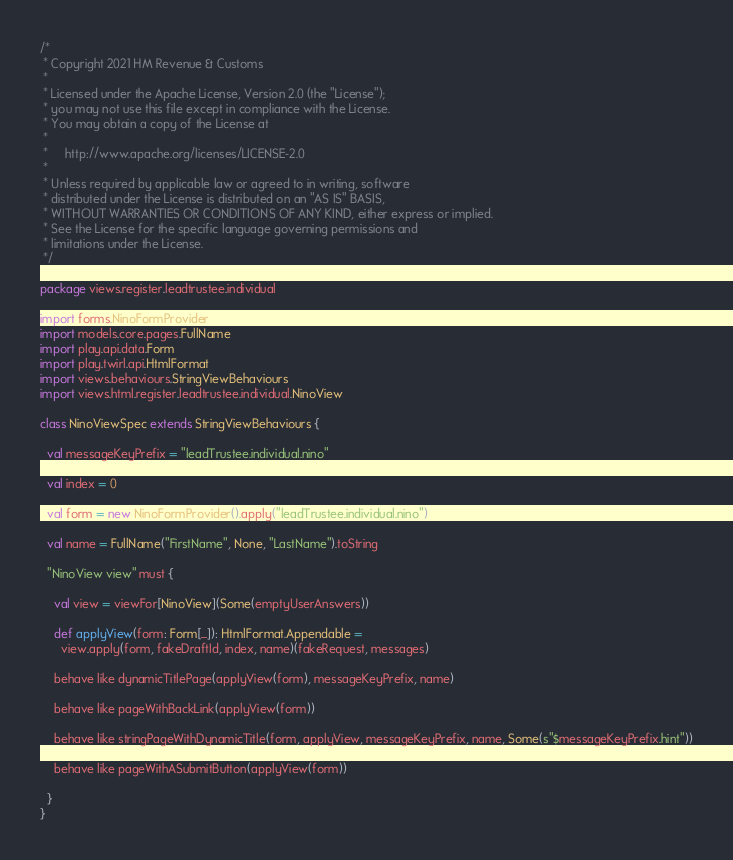Convert code to text. <code><loc_0><loc_0><loc_500><loc_500><_Scala_>/*
 * Copyright 2021 HM Revenue & Customs
 *
 * Licensed under the Apache License, Version 2.0 (the "License");
 * you may not use this file except in compliance with the License.
 * You may obtain a copy of the License at
 *
 *     http://www.apache.org/licenses/LICENSE-2.0
 *
 * Unless required by applicable law or agreed to in writing, software
 * distributed under the License is distributed on an "AS IS" BASIS,
 * WITHOUT WARRANTIES OR CONDITIONS OF ANY KIND, either express or implied.
 * See the License for the specific language governing permissions and
 * limitations under the License.
 */

package views.register.leadtrustee.individual

import forms.NinoFormProvider
import models.core.pages.FullName
import play.api.data.Form
import play.twirl.api.HtmlFormat
import views.behaviours.StringViewBehaviours
import views.html.register.leadtrustee.individual.NinoView

class NinoViewSpec extends StringViewBehaviours {

  val messageKeyPrefix = "leadTrustee.individual.nino"

  val index = 0

  val form = new NinoFormProvider().apply("leadTrustee.individual.nino")

  val name = FullName("FirstName", None, "LastName").toString

  "NinoView view" must {

    val view = viewFor[NinoView](Some(emptyUserAnswers))

    def applyView(form: Form[_]): HtmlFormat.Appendable =
      view.apply(form, fakeDraftId, index, name)(fakeRequest, messages)

    behave like dynamicTitlePage(applyView(form), messageKeyPrefix, name)

    behave like pageWithBackLink(applyView(form))

    behave like stringPageWithDynamicTitle(form, applyView, messageKeyPrefix, name, Some(s"$messageKeyPrefix.hint"))

    behave like pageWithASubmitButton(applyView(form))

  }
}
</code> 